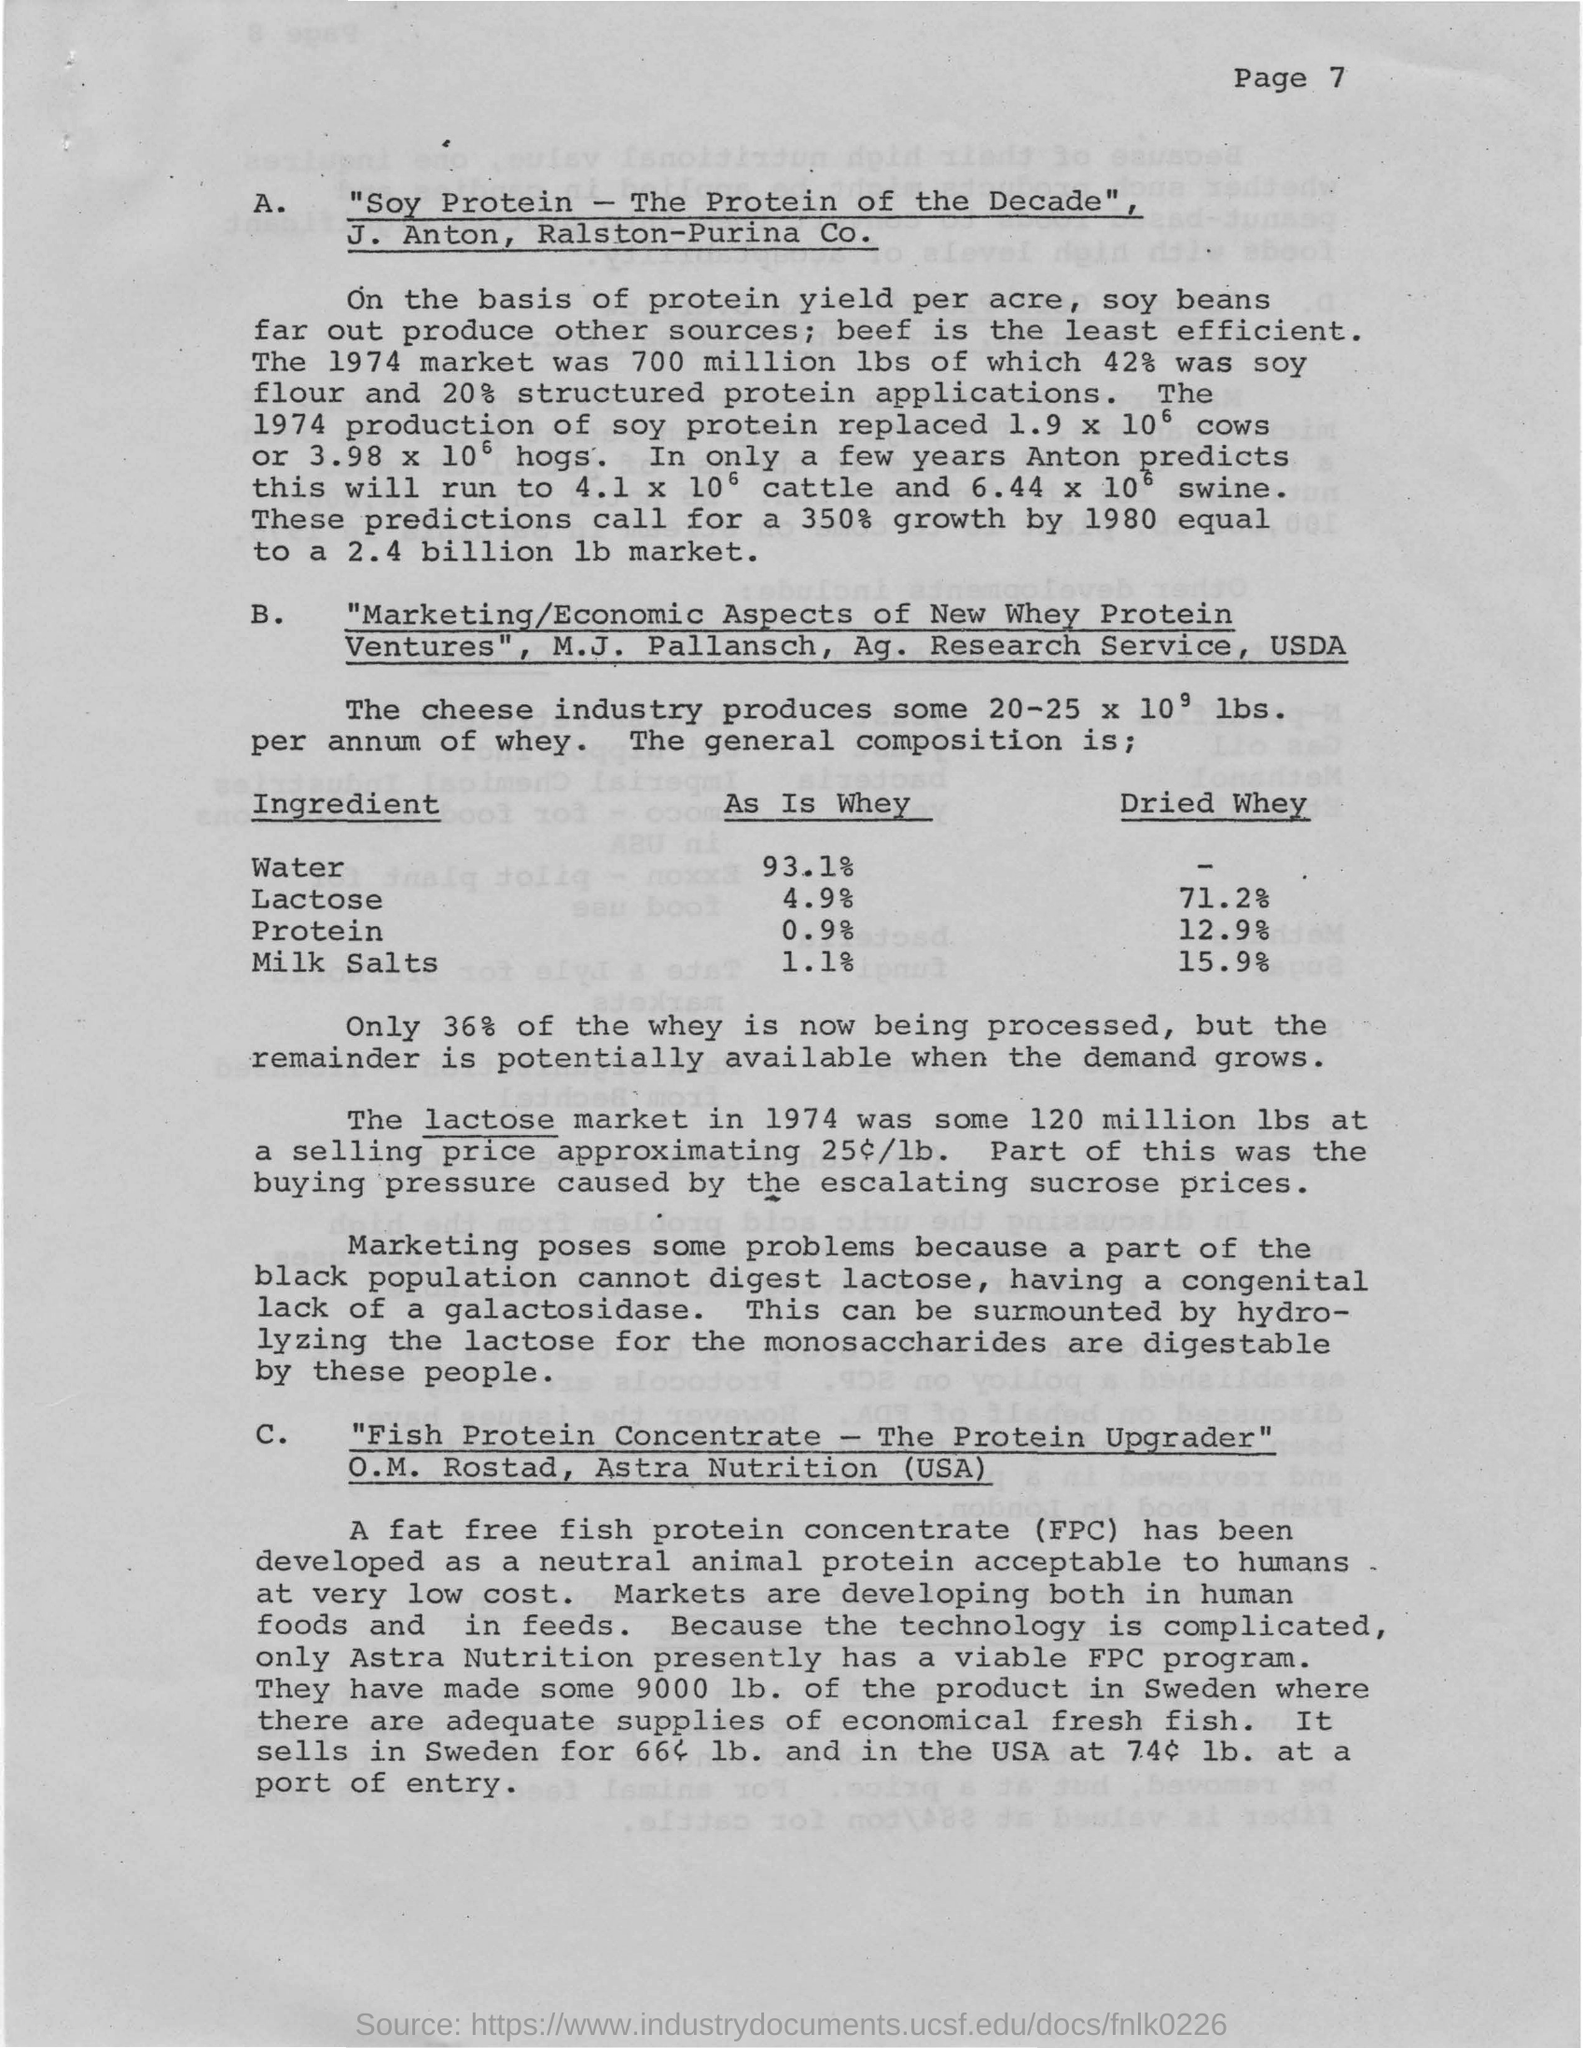List a handful of essential elements in this visual. The page number of the document is 7. 